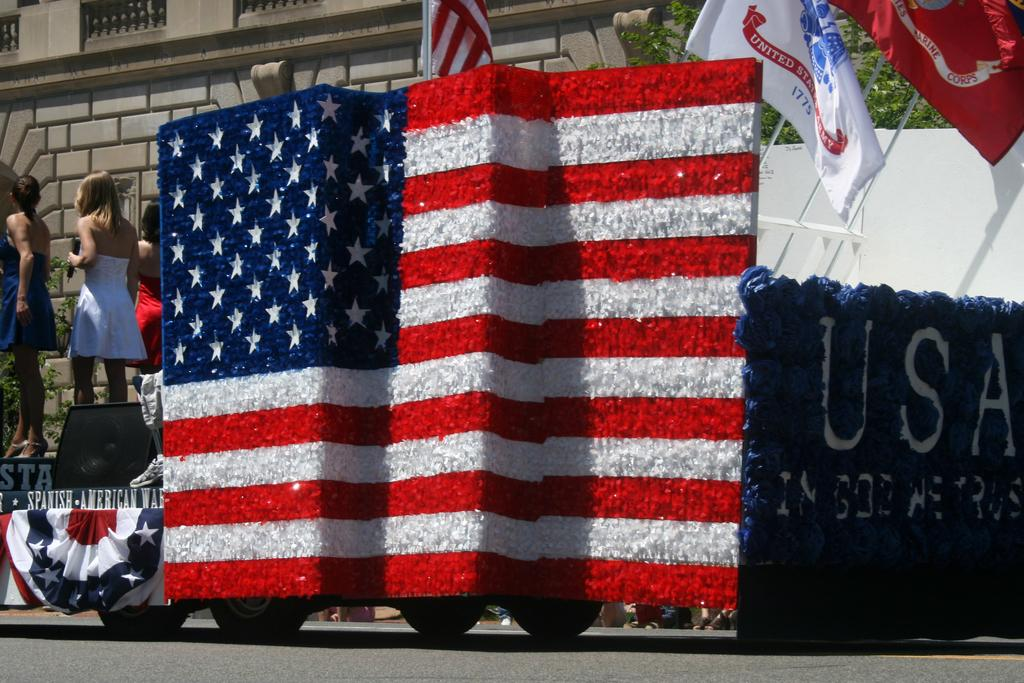<image>
Describe the image concisely. A parade is taking place in a town with a float with an American flag on the side. 